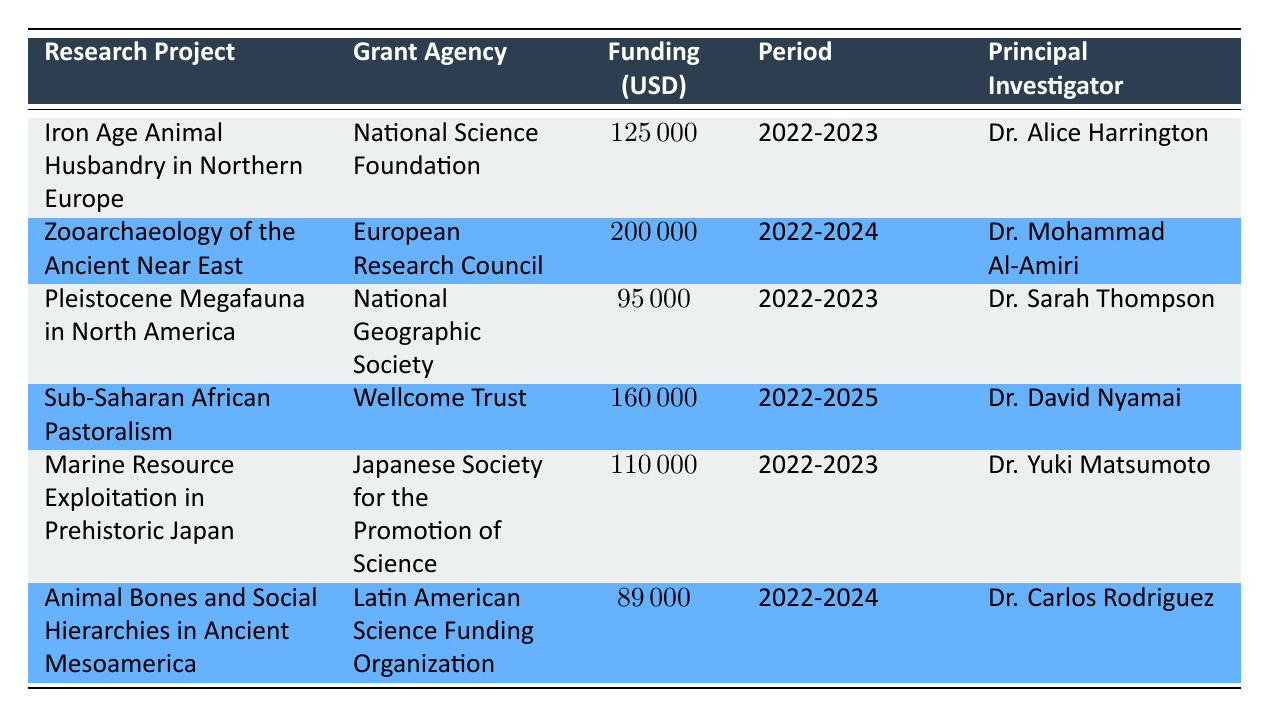What is the total funding amount for all research projects listed? To find the total funding amount, I will sum the funding amounts of each project: 125000 + 200000 + 95000 + 160000 + 110000 + 89000 = 880000.
Answer: 880000 Who is the principal investigator for the project "Zooarchaeology of the Ancient Near East"? Referring to the table, the principal investigator for this project is Dr. Mohammad Al-Amiri.
Answer: Dr. Mohammad Al-Amiri Which project has the largest funding amount and what is that amount? Scanning through the funding amounts, the largest amount is 200000 associated with the project "Zooarchaeology of the Ancient Near East".
Answer: 200000 Is there a project that lasts from 2022 to 2023? Yes, there are multiple projects that have a funding period of 2022-2023, which includes "Iron Age Animal Husbandry in Northern Europe", "Pleistocene Megafauna in North America", and "Marine Resource Exploitation in Prehistoric Japan".
Answer: Yes What is the average funding amount for projects with a duration of 2022-2023? The projects are "Iron Age Animal Husbandry in Northern Europe", "Pleistocene Megafauna in North America", and "Marine Resource Exploitation in Prehistoric Japan". Their funding amounts are 125000, 95000, and 110000, respectively. Summing these gives 125000 + 95000 + 110000 = 330000. There are 3 projects, so the average is 330000 / 3 = 110000.
Answer: 110000 How many projects are affiliated with institutions outside Europe? The projects affiliated with institutions outside Europe are "Sub-Saharan African Pastoralism" (University of Nairobi) and "Marine Resource Exploitation in Prehistoric Japan" (Kyoto University). These are the only two projects not affiliated with European institutions.
Answer: 2 What is the minimum funding amount among the projects listed? Checking the funding amounts, the minimum funding amount is found by comparing all the entries. The smallest amount is 89000 from the project "Animal Bones and Social Hierarchies in Ancient Mesoamerica".
Answer: 89000 Is the project "Animal Bones and Social Hierarchies in Ancient Mesoamerica" funded by the European Research Council? The project is funded by the Latin American Science Funding Organization, so the answer is no.
Answer: No 